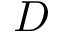Convert formula to latex. <formula><loc_0><loc_0><loc_500><loc_500>D</formula> 